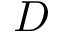Convert formula to latex. <formula><loc_0><loc_0><loc_500><loc_500>D</formula> 